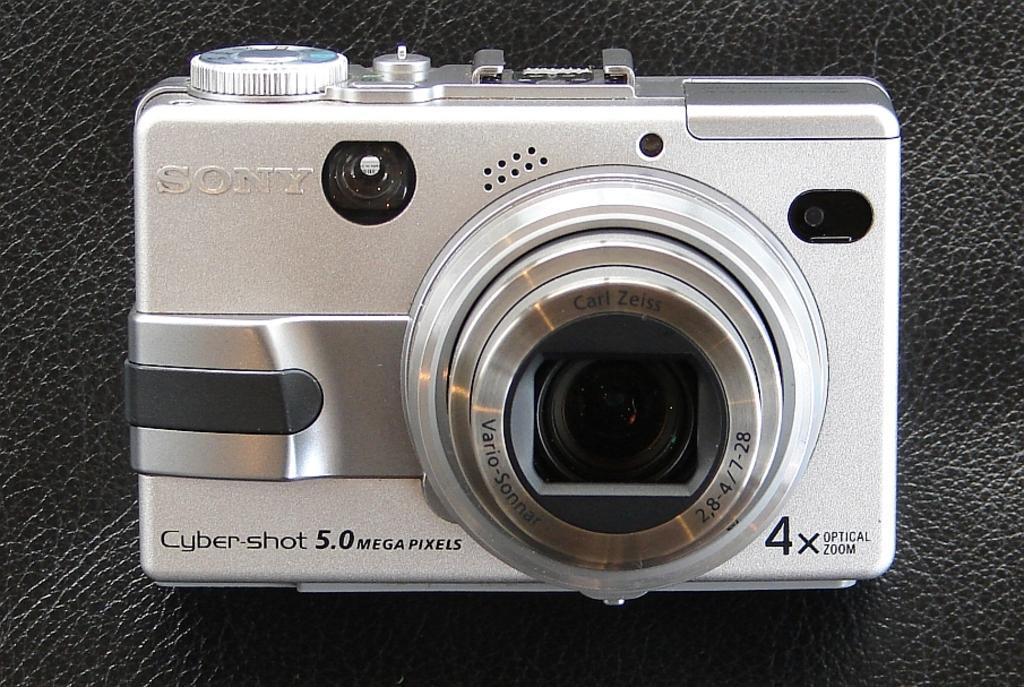How would you summarize this image in a sentence or two? In the image we can see there is a camera kept on the table and its written ¨Song¨ on it. 